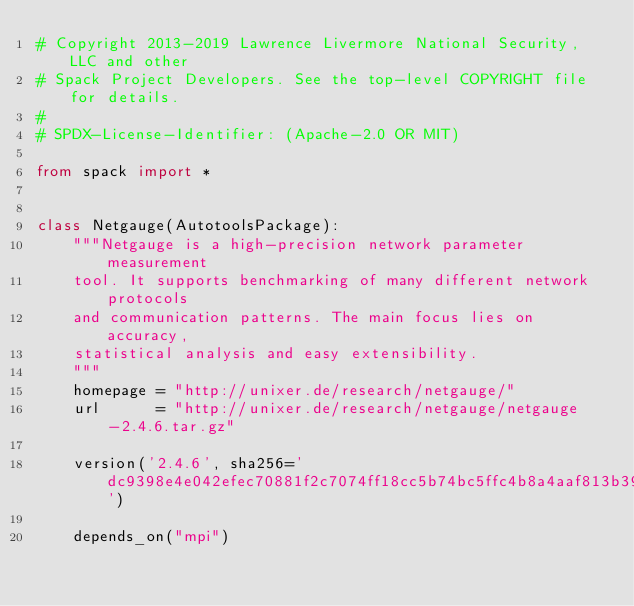<code> <loc_0><loc_0><loc_500><loc_500><_Python_># Copyright 2013-2019 Lawrence Livermore National Security, LLC and other
# Spack Project Developers. See the top-level COPYRIGHT file for details.
#
# SPDX-License-Identifier: (Apache-2.0 OR MIT)

from spack import *


class Netgauge(AutotoolsPackage):
    """Netgauge is a high-precision network parameter measurement
    tool. It supports benchmarking of many different network protocols
    and communication patterns. The main focus lies on accuracy,
    statistical analysis and easy extensibility.
    """
    homepage = "http://unixer.de/research/netgauge/"
    url      = "http://unixer.de/research/netgauge/netgauge-2.4.6.tar.gz"

    version('2.4.6', sha256='dc9398e4e042efec70881f2c7074ff18cc5b74bc5ffc4b8a4aaf813b39f83444')

    depends_on("mpi")
</code> 